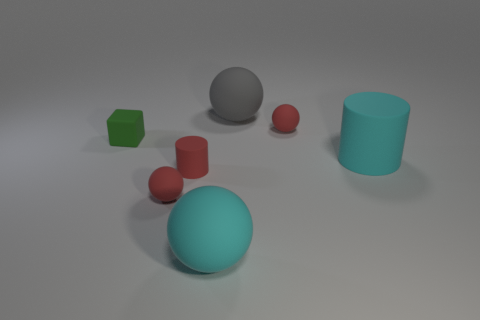Are the small cube and the large gray thing behind the tiny green block made of the same material?
Your response must be concise. Yes. What number of objects are either small matte things that are to the left of the gray sphere or matte things in front of the small block?
Give a very brief answer. 5. What number of other things are the same color as the big cylinder?
Your response must be concise. 1. Are there more balls that are left of the big cyan sphere than rubber cylinders that are in front of the green thing?
Your response must be concise. No. Are there any other things that are the same size as the cyan cylinder?
Your response must be concise. Yes. How many cylinders are either things or gray rubber things?
Offer a very short reply. 2. What number of objects are small objects behind the tiny rubber block or gray rubber objects?
Offer a very short reply. 2. What shape is the red rubber object on the right side of the large rubber sphere that is left of the large gray matte sphere that is left of the big cylinder?
Your answer should be very brief. Sphere. What number of other gray rubber objects are the same shape as the large gray matte object?
Give a very brief answer. 0. There is a big thing left of the large ball that is behind the green block; how many large things are right of it?
Your answer should be compact. 2. 